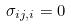<formula> <loc_0><loc_0><loc_500><loc_500>\sigma _ { i j , i } = 0</formula> 